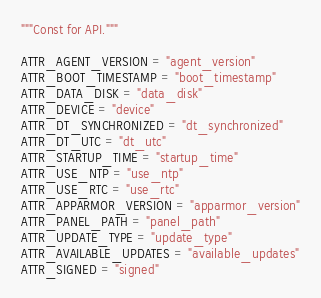<code> <loc_0><loc_0><loc_500><loc_500><_Python_>"""Const for API."""

ATTR_AGENT_VERSION = "agent_version"
ATTR_BOOT_TIMESTAMP = "boot_timestamp"
ATTR_DATA_DISK = "data_disk"
ATTR_DEVICE = "device"
ATTR_DT_SYNCHRONIZED = "dt_synchronized"
ATTR_DT_UTC = "dt_utc"
ATTR_STARTUP_TIME = "startup_time"
ATTR_USE_NTP = "use_ntp"
ATTR_USE_RTC = "use_rtc"
ATTR_APPARMOR_VERSION = "apparmor_version"
ATTR_PANEL_PATH = "panel_path"
ATTR_UPDATE_TYPE = "update_type"
ATTR_AVAILABLE_UPDATES = "available_updates"
ATTR_SIGNED = "signed"
</code> 